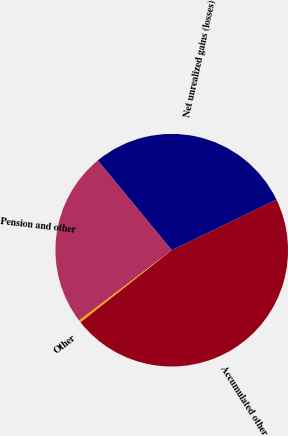Convert chart. <chart><loc_0><loc_0><loc_500><loc_500><pie_chart><fcel>Net unrealized gains (losses)<fcel>Pension and other<fcel>Other<fcel>Accumulated other<nl><fcel>28.82%<fcel>24.37%<fcel>0.31%<fcel>46.5%<nl></chart> 